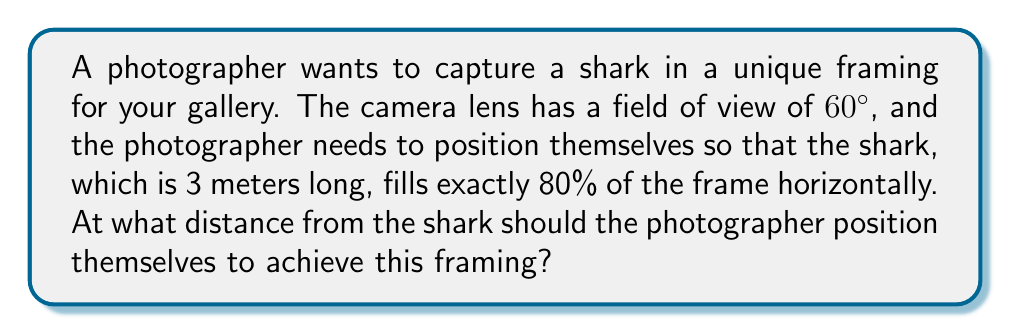Could you help me with this problem? Let's approach this step-by-step:

1) First, we need to understand what 80% of the frame means. If the shark fills 80% of the frame horizontally, it means that the shark's length (3 meters) corresponds to 80% of the width of the field of view at the distance where the photo is taken.

2) Let's call the distance from the shark to the photographer $d$. This forms a right triangle where:
   - The angle at the camera is 60° (the field of view)
   - The opposite side to this angle is the width of the field of view
   - The adjacent side is the distance $d$

3) We can use trigonometry to set up an equation. The tangent of half the field of view angle will give us the ratio of half the frame width to the distance:

   $$\tan(30°) = \frac{\text{half frame width}}{d}$$

4) We know that the shark's length (3 m) is 80% of the frame width. So the full frame width is $3/0.8 = 3.75$ m, and half of that is 1.875 m.

5) Now we can substitute this into our equation:

   $$\tan(30°) = \frac{1.875}{d}$$

6) Solving for $d$:

   $$d = \frac{1.875}{\tan(30°)}$$

7) We know that $\tan(30°) = \frac{1}{\sqrt{3}}$, so:

   $$d = 1.875 \cdot \sqrt{3} \approx 3.25 \text{ m}$$
Answer: $3.25 \text{ m}$ 